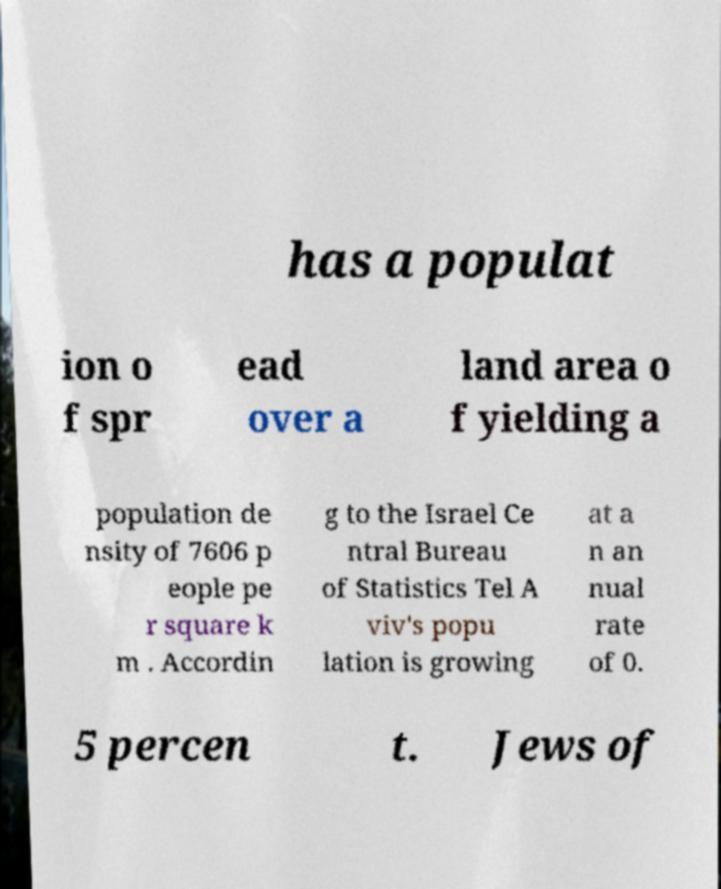Could you extract and type out the text from this image? has a populat ion o f spr ead over a land area o f yielding a population de nsity of 7606 p eople pe r square k m . Accordin g to the Israel Ce ntral Bureau of Statistics Tel A viv's popu lation is growing at a n an nual rate of 0. 5 percen t. Jews of 